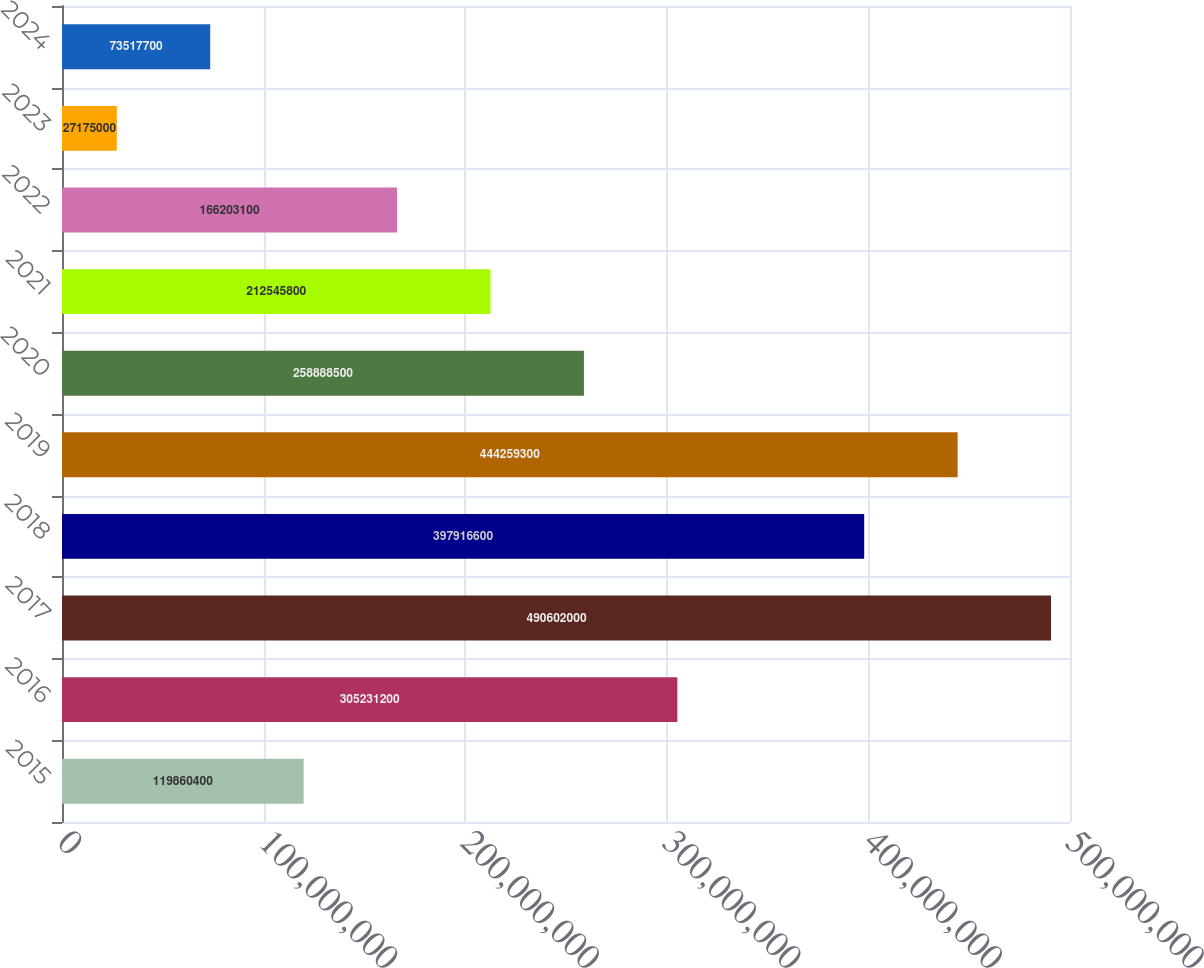<chart> <loc_0><loc_0><loc_500><loc_500><bar_chart><fcel>2015<fcel>2016<fcel>2017<fcel>2018<fcel>2019<fcel>2020<fcel>2021<fcel>2022<fcel>2023<fcel>2024<nl><fcel>1.1986e+08<fcel>3.05231e+08<fcel>4.90602e+08<fcel>3.97917e+08<fcel>4.44259e+08<fcel>2.58888e+08<fcel>2.12546e+08<fcel>1.66203e+08<fcel>2.7175e+07<fcel>7.35177e+07<nl></chart> 